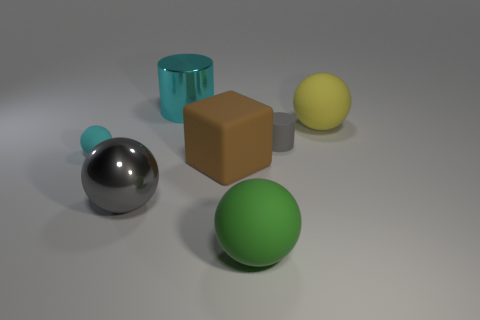Is the number of cyan cylinders that are left of the large brown rubber object greater than the number of green rubber spheres that are behind the large cyan object?
Provide a short and direct response. Yes. The metal thing that is the same shape as the large yellow matte thing is what color?
Ensure brevity in your answer.  Gray. Is there any other thing that is the same shape as the brown matte thing?
Your answer should be very brief. No. Is the shape of the brown rubber thing the same as the cyan thing that is behind the small cyan object?
Your response must be concise. No. How many other things are there of the same material as the gray ball?
Keep it short and to the point. 1. Is the color of the matte cylinder the same as the thing that is behind the big yellow thing?
Provide a succinct answer. No. There is a large ball left of the big green matte thing; what is it made of?
Provide a succinct answer. Metal. Are there any shiny cylinders that have the same color as the shiny sphere?
Offer a very short reply. No. The metallic ball that is the same size as the brown matte thing is what color?
Offer a very short reply. Gray. How many small things are purple matte things or brown matte objects?
Your answer should be very brief. 0. 